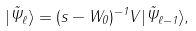Convert formula to latex. <formula><loc_0><loc_0><loc_500><loc_500>| \tilde { \Psi } _ { \ell } \rangle = ( s - W _ { 0 } ) ^ { - 1 } V | \tilde { \Psi } _ { \ell - 1 } \rangle ,</formula> 